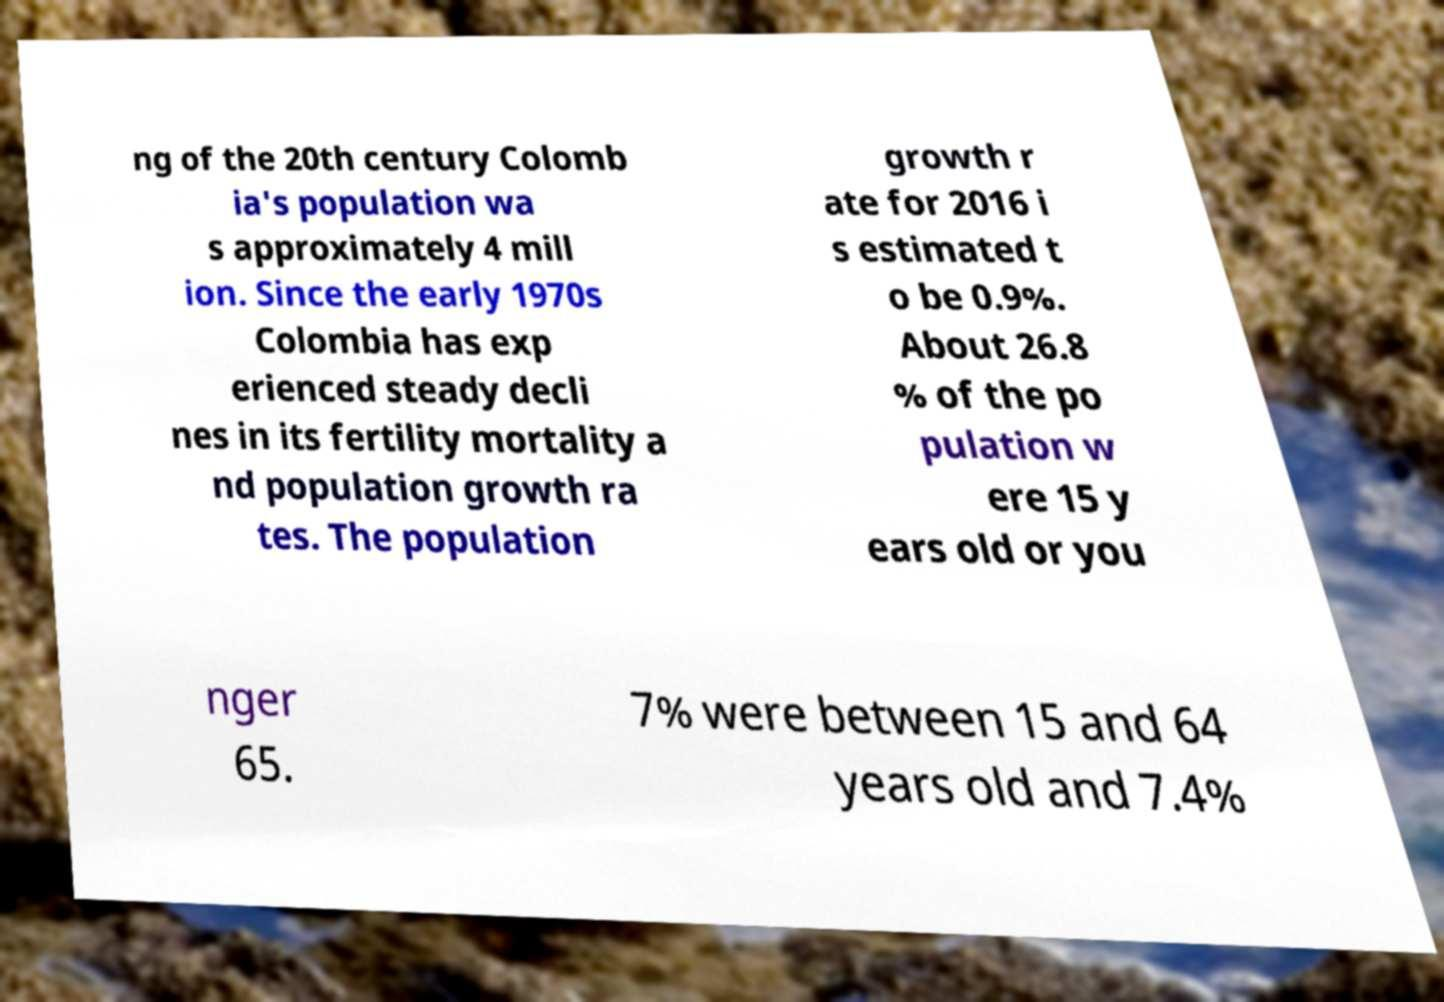I need the written content from this picture converted into text. Can you do that? ng of the 20th century Colomb ia's population wa s approximately 4 mill ion. Since the early 1970s Colombia has exp erienced steady decli nes in its fertility mortality a nd population growth ra tes. The population growth r ate for 2016 i s estimated t o be 0.9%. About 26.8 % of the po pulation w ere 15 y ears old or you nger 65. 7% were between 15 and 64 years old and 7.4% 